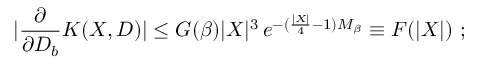<formula> <loc_0><loc_0><loc_500><loc_500>| \frac { \partial } { \partial D _ { b } } K ( X , D ) | \leq G ( \beta ) | X | ^ { 3 } \, e ^ { - ( \frac { | X | } { 4 } - 1 ) M _ { \beta } } \equiv F ( | X | ) \ ;</formula> 